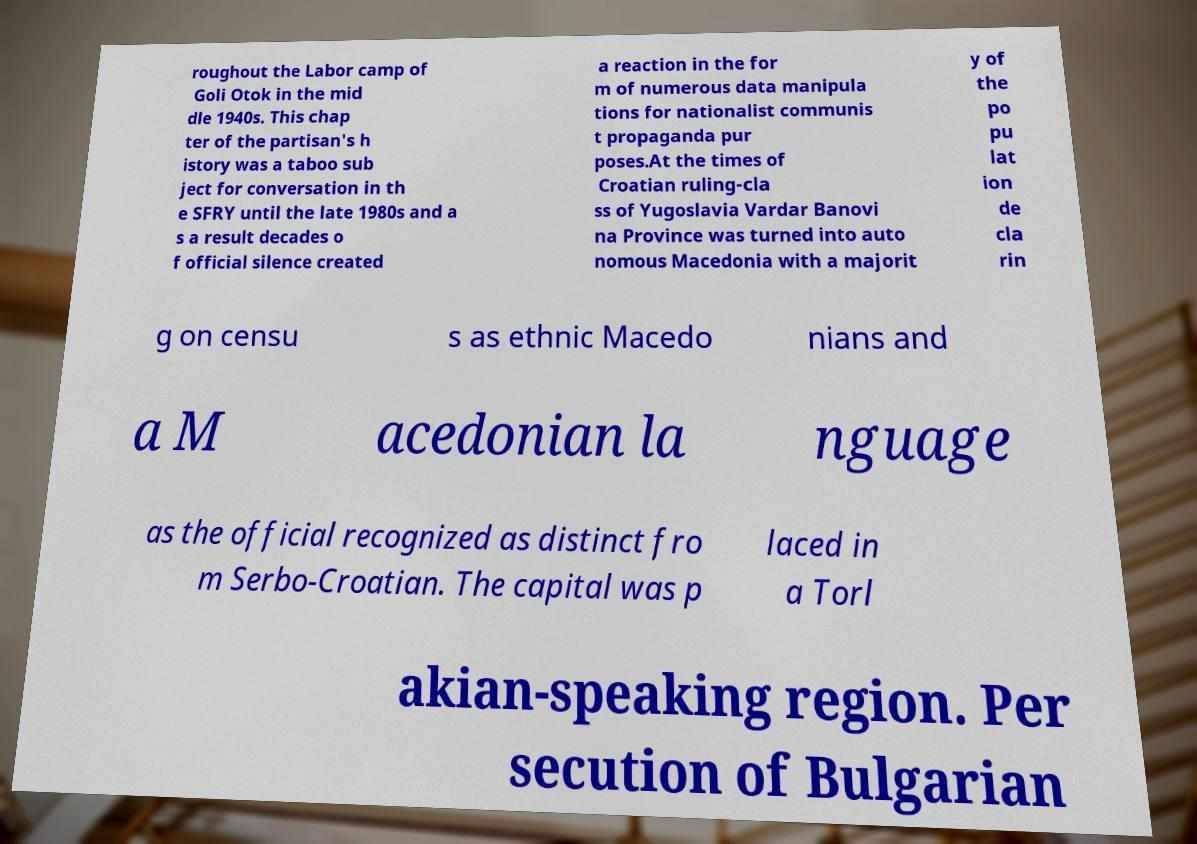Could you extract and type out the text from this image? roughout the Labor camp of Goli Otok in the mid dle 1940s. This chap ter of the partisan's h istory was a taboo sub ject for conversation in th e SFRY until the late 1980s and a s a result decades o f official silence created a reaction in the for m of numerous data manipula tions for nationalist communis t propaganda pur poses.At the times of Croatian ruling-cla ss of Yugoslavia Vardar Banovi na Province was turned into auto nomous Macedonia with a majorit y of the po pu lat ion de cla rin g on censu s as ethnic Macedo nians and a M acedonian la nguage as the official recognized as distinct fro m Serbo-Croatian. The capital was p laced in a Torl akian-speaking region. Per secution of Bulgarian 